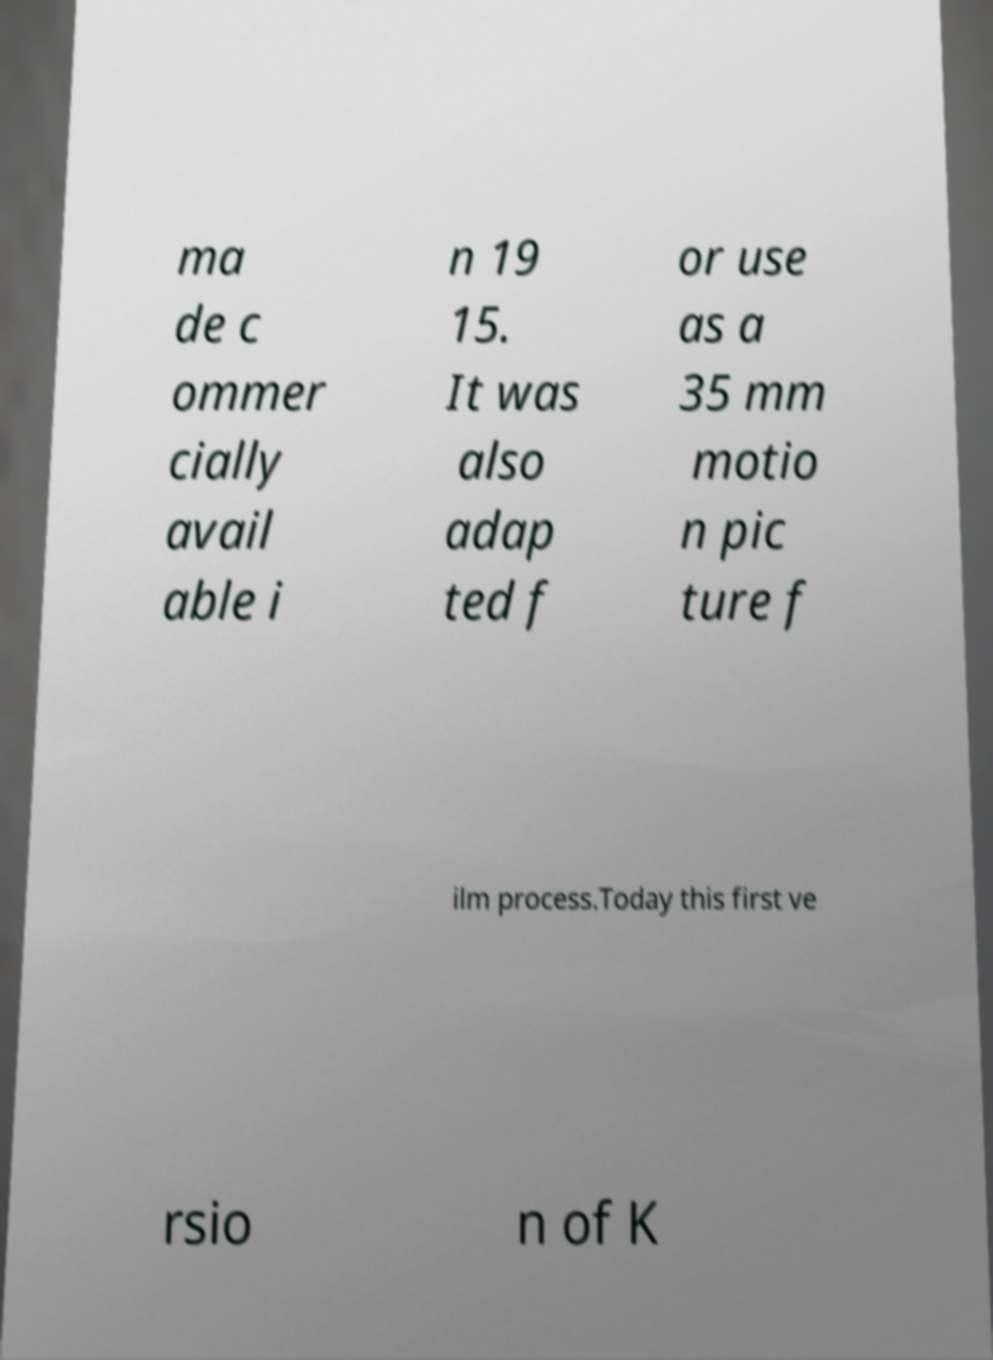Please identify and transcribe the text found in this image. ma de c ommer cially avail able i n 19 15. It was also adap ted f or use as a 35 mm motio n pic ture f ilm process.Today this first ve rsio n of K 